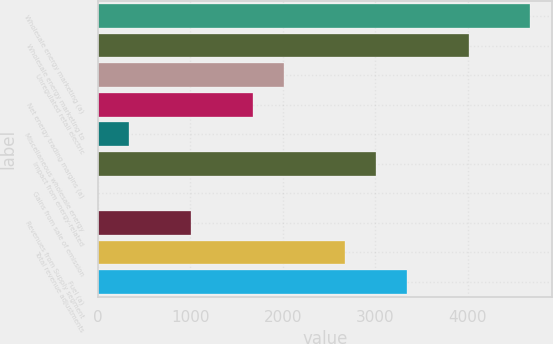<chart> <loc_0><loc_0><loc_500><loc_500><bar_chart><fcel>Wholesale energy marketing (a)<fcel>Wholesale energy marketing to<fcel>Unregulated retail electric<fcel>Net energy trading margins (a)<fcel>Miscellaneous wholesale energy<fcel>Impact from energy-related<fcel>Gains from sale of emission<fcel>Revenues from Supply segment<fcel>Total revenue adjustments<fcel>Fuel (a)<nl><fcel>4679.2<fcel>4011.6<fcel>2008.8<fcel>1675<fcel>339.8<fcel>3010.2<fcel>6<fcel>1007.4<fcel>2676.4<fcel>3344<nl></chart> 